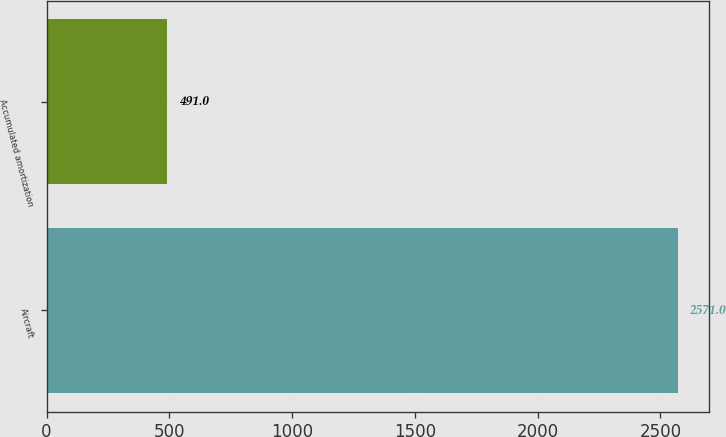Convert chart to OTSL. <chart><loc_0><loc_0><loc_500><loc_500><bar_chart><fcel>Aircraft<fcel>Accumulated amortization<nl><fcel>2571<fcel>491<nl></chart> 